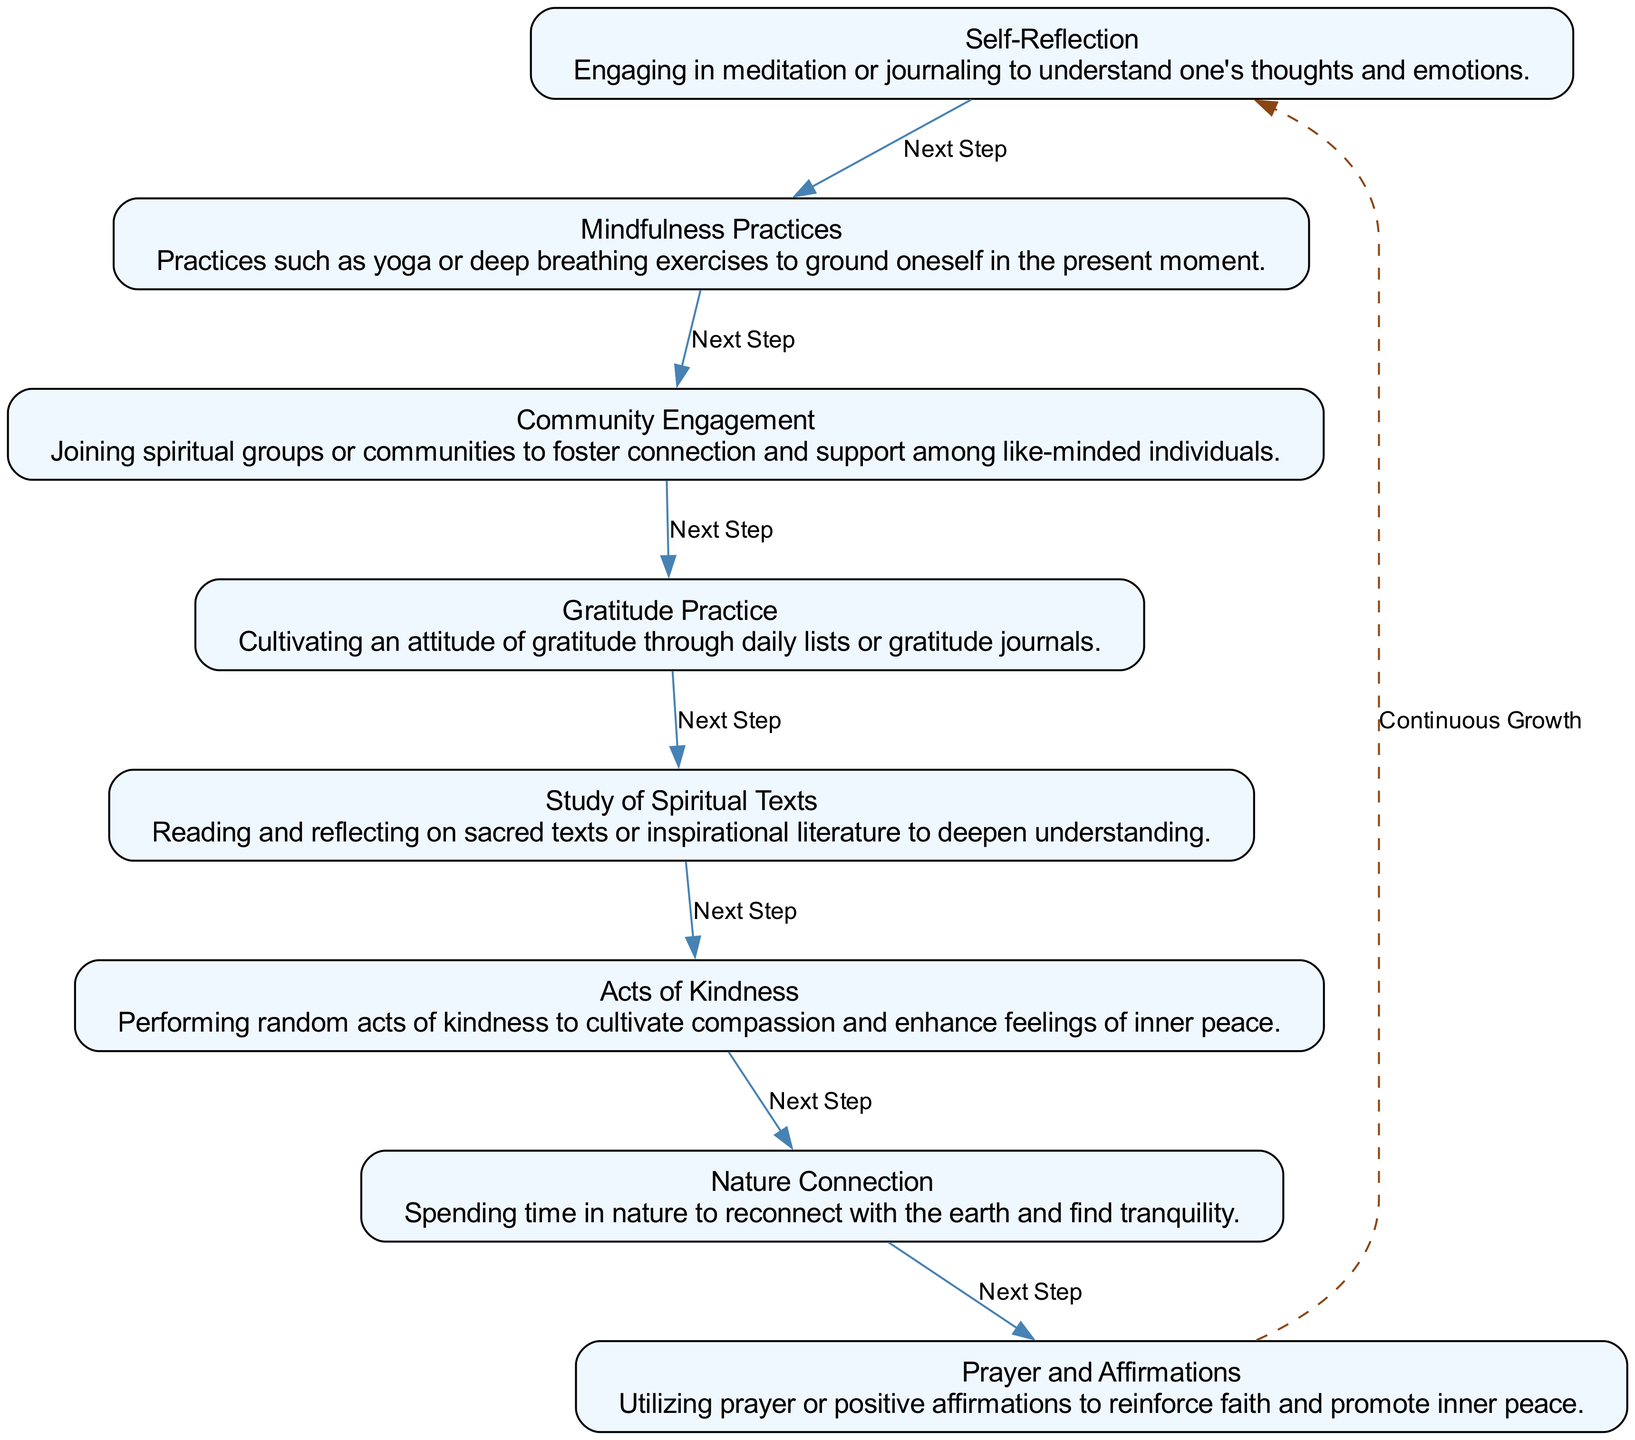What is the first step in the path of spiritual growth? The first step listed in the diagram is self-reflection, as it appears at the top of the flow chart and is the starting node.
Answer: Self-Reflection How many steps are included in the diagram? The flow chart lists a total of eight distinct steps, as evidenced by the eight nodes representing different practices related to spiritual growth.
Answer: Eight Which step comes after "Community Engagement"? After "Community Engagement", the next step in the flow chart is "Gratitude Practice", which follows directly from the edge connecting these two nodes.
Answer: Gratitude Practice What type of practices are located in the middle of the flow chart? The middle steps represented in the flow chart include "Mindfulness Practices", "Community Engagement", and "Gratitude Practice", which collectively focus on enhancing one's spiritual life through interpersonal connections and self-awareness practices.
Answer: Mindfulness Practices, Community Engagement, Gratitude Practice Which step emphasizes cultivating an attitude of appreciation? The step that emphasizes cultivating an attitude of appreciation is "Gratitude Practice", clearly associated with acknowledging and listing things one is thankful for.
Answer: Gratitude Practice What is the relationship between "Acts of Kindness" and "Nature Connection"? The relationship is sequential; "Acts of Kindness" directly precedes "Nature Connection". This indicates that one may engage in acts of kindness before exploring the tranquility found in nature.
Answer: Sequential; "Acts of Kindness" precedes "Nature Connection" Is there a connection between "Self-Reflection" and "Prayer and Affirmations"? Yes, there is a connection through the flow chart, which shows that "Self-Reflection" leads to "Mindfulness Practices," continuing through the subsequent steps until reaching "Prayer and Affirmations", indicating the progression of spiritual practices.
Answer: Yes, they are connected through the flow How does the flow chart illustrate continuous growth? The diagram illustrates continuous growth by showing a dashed edge that connects the last step back to "Self-Reflection", implying that spiritual growth is a cyclical and ongoing process, encouraging individuals to return to the practices for further development.
Answer: Through a dashed edge connecting back to "Self-Reflection" for continuous growth 